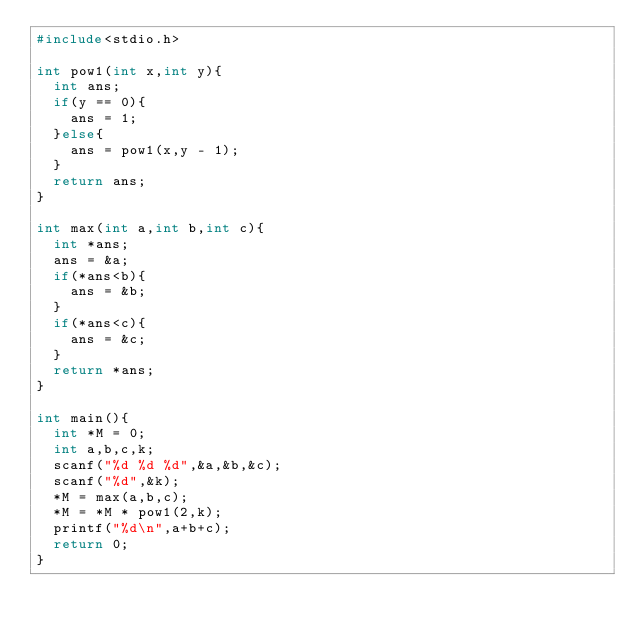<code> <loc_0><loc_0><loc_500><loc_500><_C_>#include<stdio.h>

int pow1(int x,int y){
  int ans;
  if(y == 0){
    ans = 1;
  }else{
    ans = pow1(x,y - 1);
  }
  return ans;
}

int max(int a,int b,int c){
  int *ans;
  ans = &a;
  if(*ans<b){
    ans = &b;
  }
  if(*ans<c){
    ans = &c;
  }
  return *ans;
}

int main(){
  int *M = 0;
  int a,b,c,k;
  scanf("%d %d %d",&a,&b,&c);
  scanf("%d",&k);
  *M = max(a,b,c);
  *M = *M * pow1(2,k);
  printf("%d\n",a+b+c);
  return 0;
}</code> 